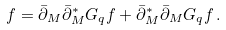Convert formula to latex. <formula><loc_0><loc_0><loc_500><loc_500>f = \bar { \partial } _ { M } \bar { \partial } ^ { * } _ { M } G _ { q } f + \bar { \partial } ^ { * } _ { M } \bar { \partial } _ { M } G _ { q } f \, .</formula> 